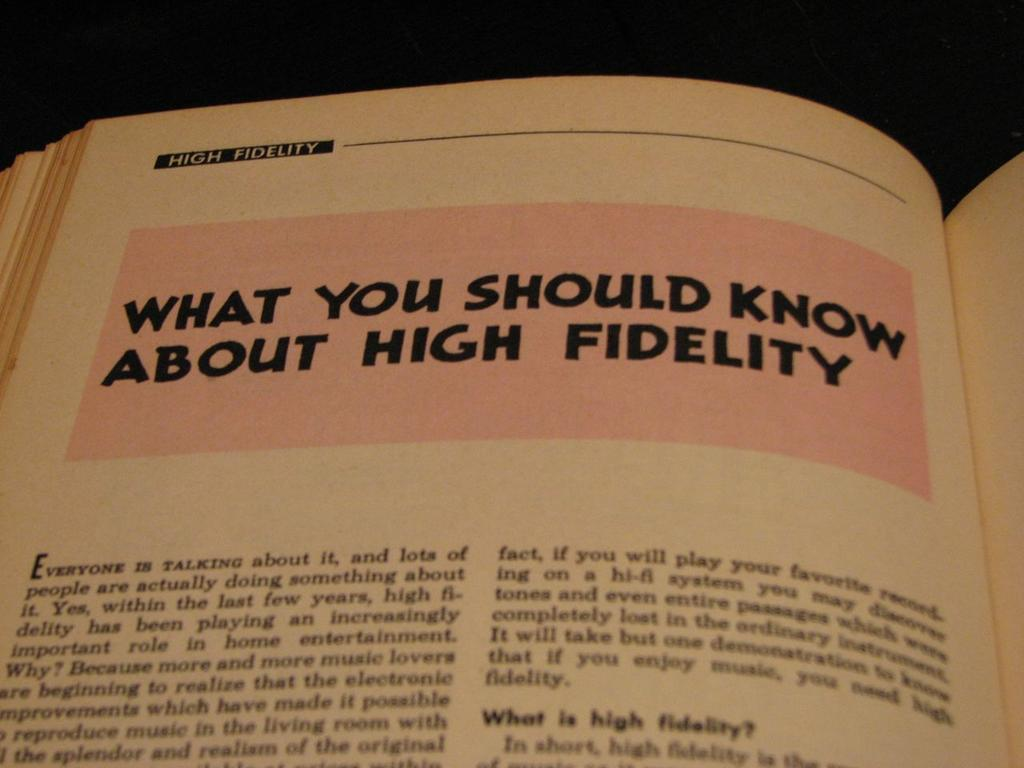<image>
Give a short and clear explanation of the subsequent image. High fidelity is the subject of one of the book's chapters. 